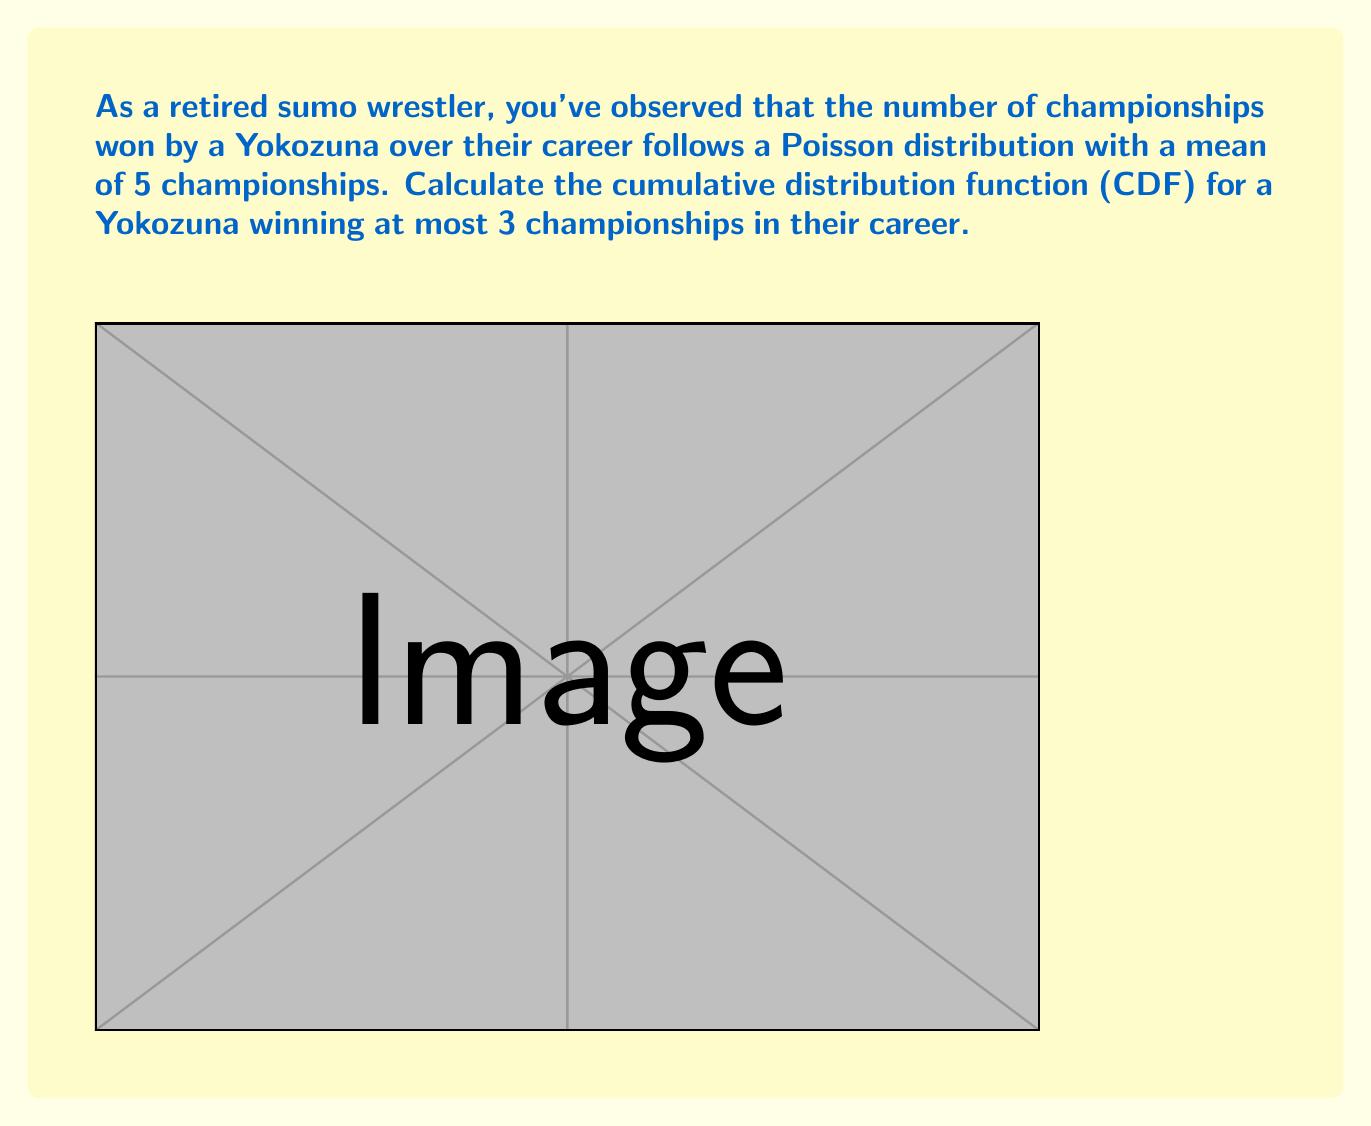Help me with this question. To solve this problem, we need to follow these steps:

1) The Poisson distribution with mean $\lambda$ has the probability mass function:

   $P(X = k) = \frac{e^{-\lambda}\lambda^k}{k!}$

   Here, $\lambda = 5$.

2) The cumulative distribution function (CDF) for a discrete random variable X is:

   $F(x) = P(X \leq x) = \sum_{k=0}^{\lfloor x \rfloor} P(X = k)$

3) We need to calculate $F(3)$, which is:

   $F(3) = P(X \leq 3) = P(X = 0) + P(X = 1) + P(X = 2) + P(X = 3)$

4) Let's calculate each term:

   $P(X = 0) = \frac{e^{-5}5^0}{0!} = e^{-5}$

   $P(X = 1) = \frac{e^{-5}5^1}{1!} = 5e^{-5}$

   $P(X = 2) = \frac{e^{-5}5^2}{2!} = \frac{25e^{-5}}{2}$

   $P(X = 3) = \frac{e^{-5}5^3}{3!} = \frac{125e^{-5}}{6}$

5) Sum these probabilities:

   $F(3) = e^{-5} + 5e^{-5} + \frac{25e^{-5}}{2} + \frac{125e^{-5}}{6}$

6) Simplify:

   $F(3) = e^{-5}(1 + 5 + \frac{25}{2} + \frac{125}{6})$
   
   $F(3) = e^{-5}(\frac{6}{6} + \frac{30}{6} + \frac{75}{6} + \frac{125}{6})$
   
   $F(3) = e^{-5}(\frac{236}{6})$

7) Calculate the final value:

   $F(3) \approx 0.2650$

Therefore, the probability that a Yokozuna wins at most 3 championships in their career is approximately 0.2650 or 26.50%.
Answer: $F(3) = e^{-5}(\frac{236}{6}) \approx 0.2650$ 